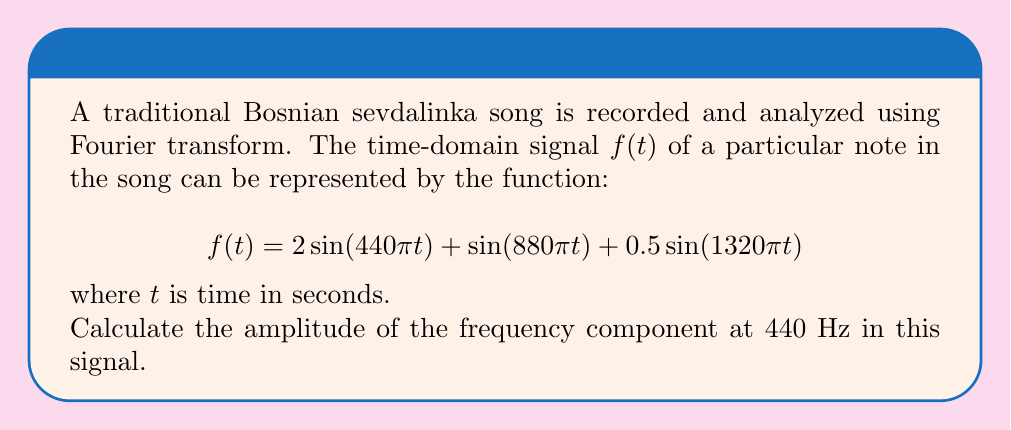Can you answer this question? To solve this problem, we'll follow these steps:

1) The given function $f(t)$ is already expressed as a sum of sinusoids, which is the time-domain representation of the signal.

2) Each sinusoid in this sum represents a frequency component of the signal. The general form of a sinusoid is $A\sin(2\pi ft)$, where $A$ is the amplitude and $f$ is the frequency in Hz.

3) Let's identify each component:
   
   a) $2\sin(440\pi t) = 2\sin(2\pi \cdot 220 \cdot t)$
   b) $\sin(880\pi t) = \sin(2\pi \cdot 440 \cdot t)$
   c) $0.5\sin(1320\pi t) = 0.5\sin(2\pi \cdot 660 \cdot t)$

4) We're interested in the 440 Hz component, which is the second term:

   $\sin(880\pi t) = \sin(2\pi \cdot 440 \cdot t)$

5) Comparing this to the general form $A\sin(2\pi ft)$, we can see that:
   
   $A = 1$ (the coefficient in front of the sine)
   $f = 440$ Hz

Therefore, the amplitude of the 440 Hz frequency component is 1.
Answer: 1 